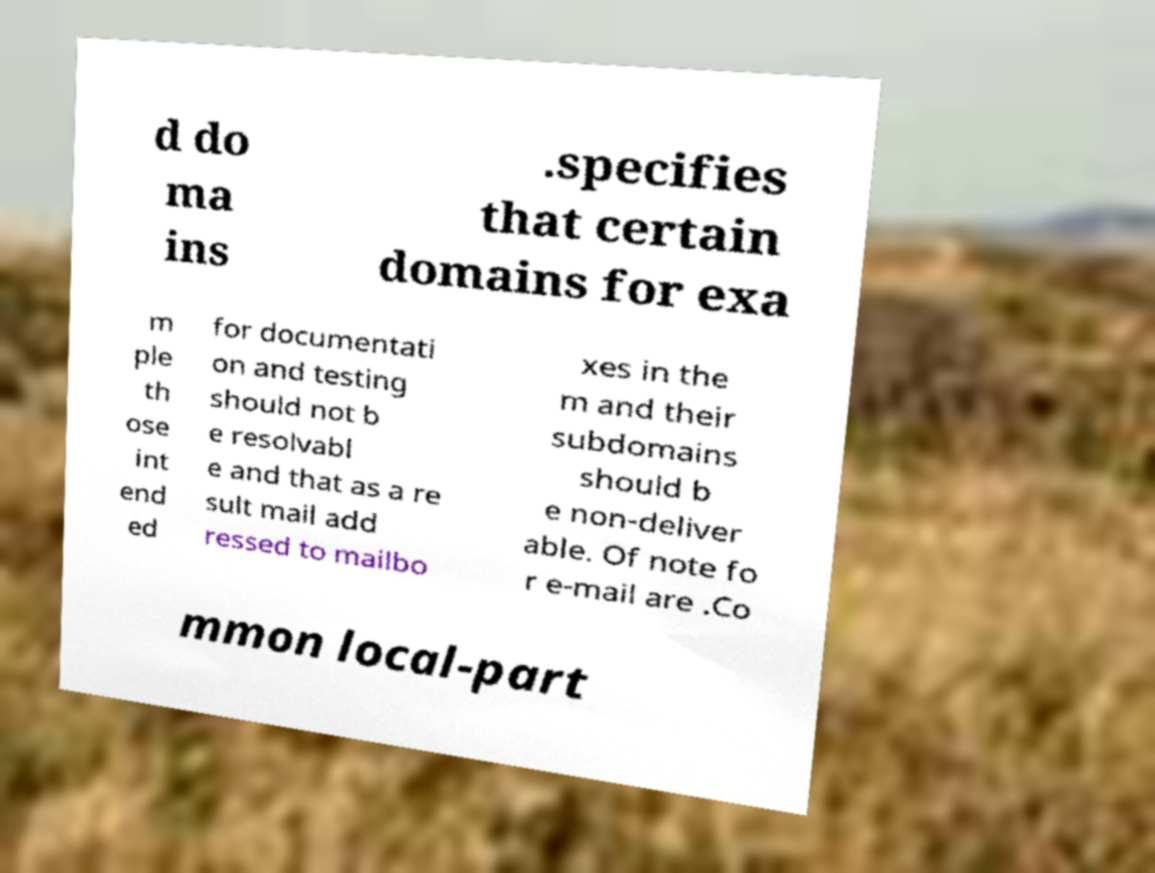Can you accurately transcribe the text from the provided image for me? d do ma ins .specifies that certain domains for exa m ple th ose int end ed for documentati on and testing should not b e resolvabl e and that as a re sult mail add ressed to mailbo xes in the m and their subdomains should b e non-deliver able. Of note fo r e-mail are .Co mmon local-part 